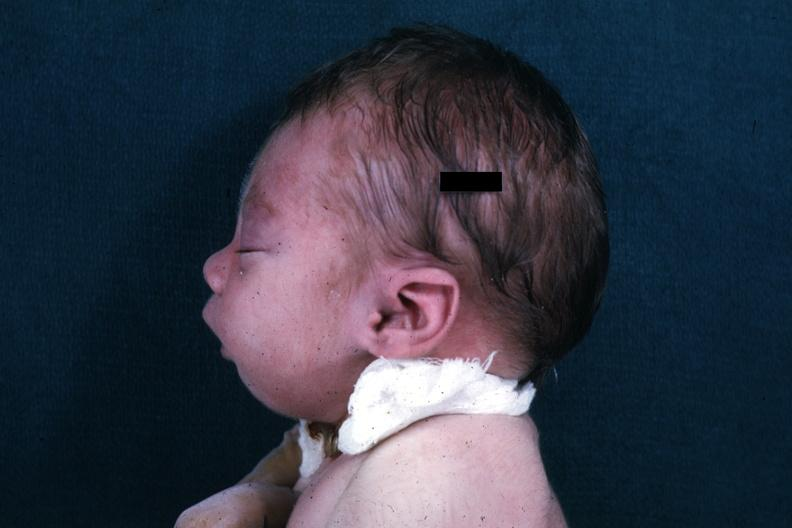s case of dic not bad photo present?
Answer the question using a single word or phrase. No 